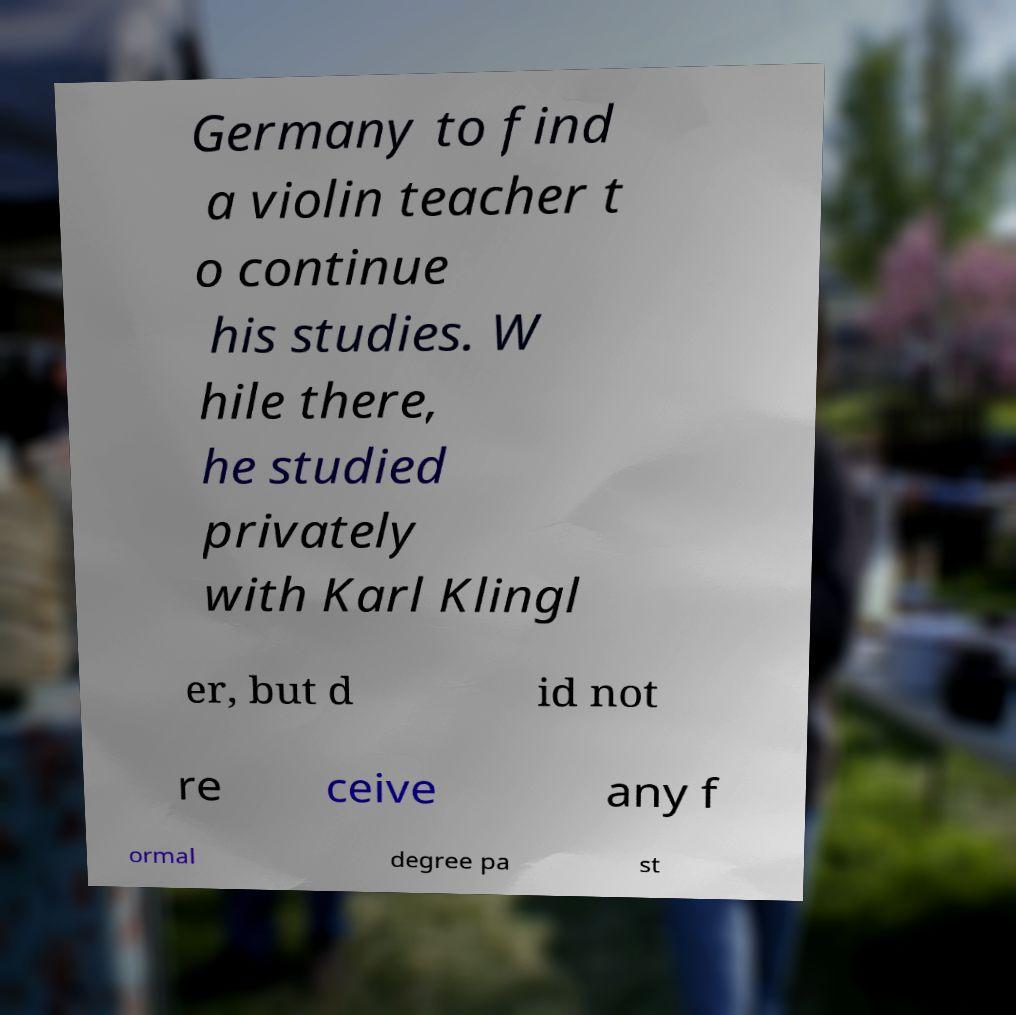What messages or text are displayed in this image? I need them in a readable, typed format. Germany to find a violin teacher t o continue his studies. W hile there, he studied privately with Karl Klingl er, but d id not re ceive any f ormal degree pa st 